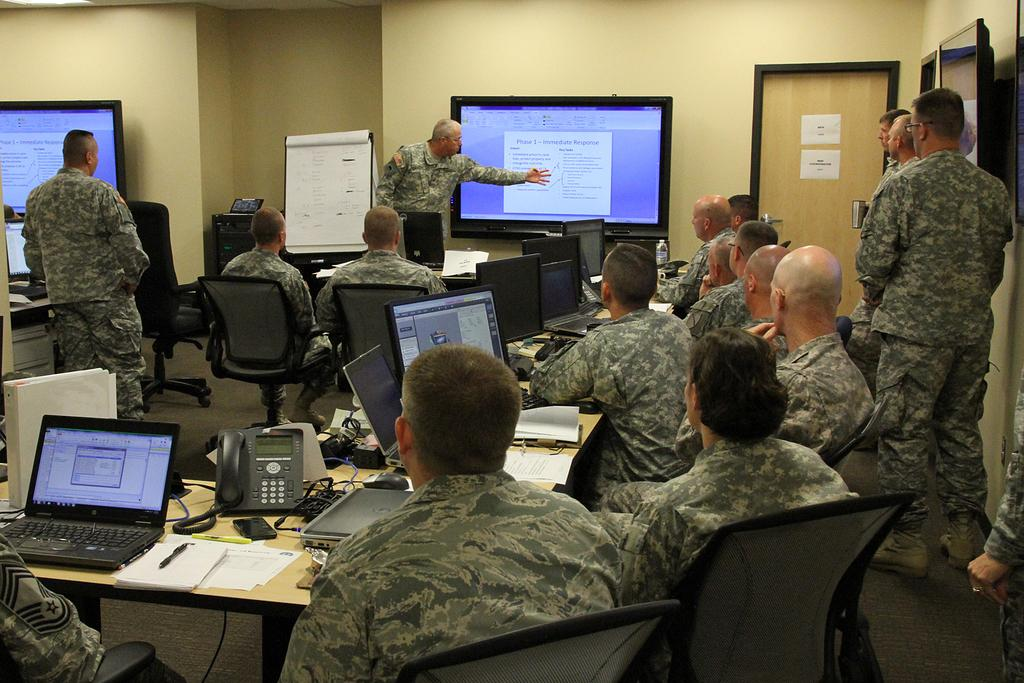What are the people in the image doing? In the image, there are men who are standing and sitting. Can you describe the setting in which the men are located? There is a projector display in the room where the men are. How many rabbits can be seen interacting with the machine in the image? There are no rabbits or machines present in the image. 